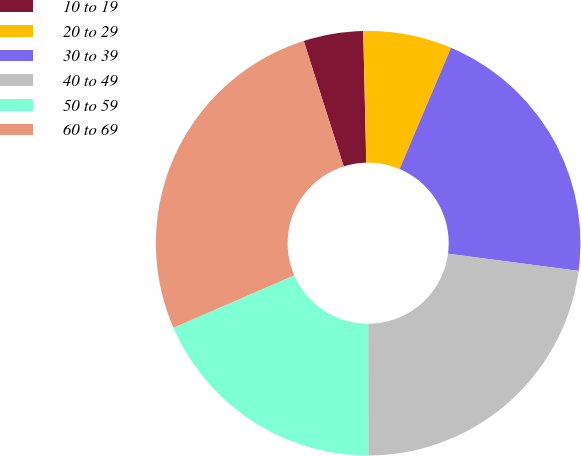<chart> <loc_0><loc_0><loc_500><loc_500><pie_chart><fcel>10 to 19<fcel>20 to 29<fcel>30 to 39<fcel>40 to 49<fcel>50 to 59<fcel>60 to 69<nl><fcel>4.54%<fcel>6.75%<fcel>20.7%<fcel>22.91%<fcel>18.49%<fcel>26.61%<nl></chart> 